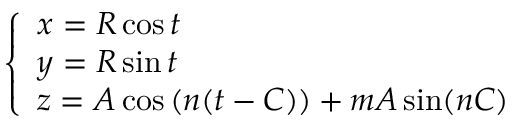<formula> <loc_0><loc_0><loc_500><loc_500>\left \{ \begin{array} { l } { x = R \cos t } \\ { y = R \sin t } \\ { z = A \cos ( n ( t - C ) ) + m A \sin ( n C ) } \end{array}</formula> 